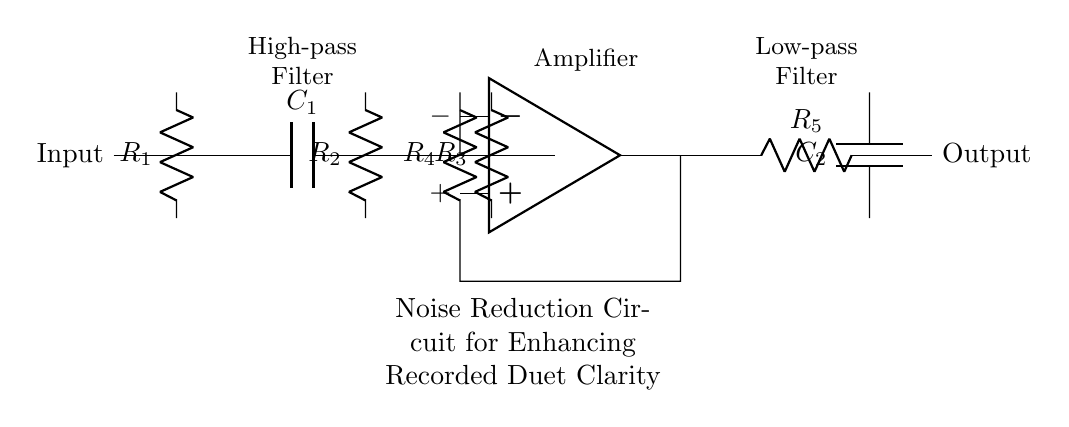What is the function of the operational amplifier in this circuit? The operational amplifier amplifies the difference between the input signals, helping to enhance the desired frequencies while reducing noise.
Answer: Amplification What type of filter is shown between the input and the operational amplifier? The high-pass filter is composed of a capacitor and resistor which allows high frequencies to pass while attenuating lower frequencies, effectively reducing noise.
Answer: High-pass filter How many resistors are present in the noise reduction circuit? There are five resistors in the circuit, denoted as R1, R2, R3, R4, and R5.
Answer: Five What components are in the low-pass filter section? The low-pass filter consists of a resistor and a capacitor connected in series, which allows low frequencies to pass and attenuates higher frequencies.
Answer: Resistor and capacitor What is the role of the capacitor labeled C1? Capacitor C1 is part of the high-pass filter which blocks lower frequency signals and allows higher frequency signals to be processed by the amplifier.
Answer: Block low frequencies Which resistor is part of the feedback loop from the operational amplifier? Resistor R4 is connected between the output of the operational amplifier and its inverting input, forming a feedback loop that helps stabilize the gain.
Answer: R4 